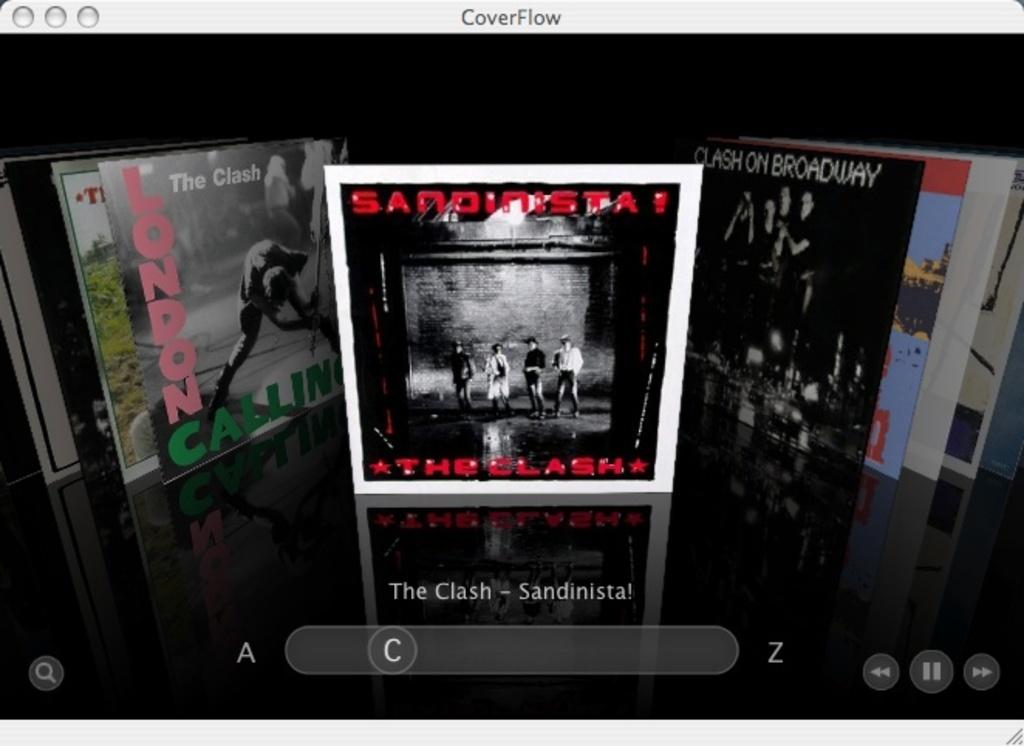What band made the album in the center?
Offer a very short reply. The clash. What city is calling/?
Ensure brevity in your answer.  London. 